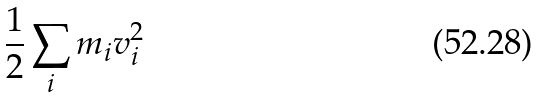<formula> <loc_0><loc_0><loc_500><loc_500>\frac { 1 } { 2 } \sum _ { i } m _ { i } v _ { i } ^ { 2 }</formula> 